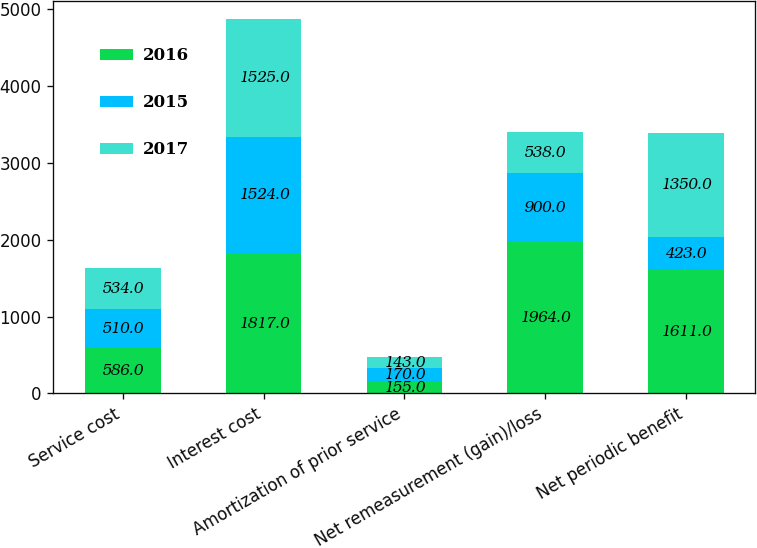Convert chart to OTSL. <chart><loc_0><loc_0><loc_500><loc_500><stacked_bar_chart><ecel><fcel>Service cost<fcel>Interest cost<fcel>Amortization of prior service<fcel>Net remeasurement (gain)/loss<fcel>Net periodic benefit<nl><fcel>2016<fcel>586<fcel>1817<fcel>155<fcel>1964<fcel>1611<nl><fcel>2015<fcel>510<fcel>1524<fcel>170<fcel>900<fcel>423<nl><fcel>2017<fcel>534<fcel>1525<fcel>143<fcel>538<fcel>1350<nl></chart> 